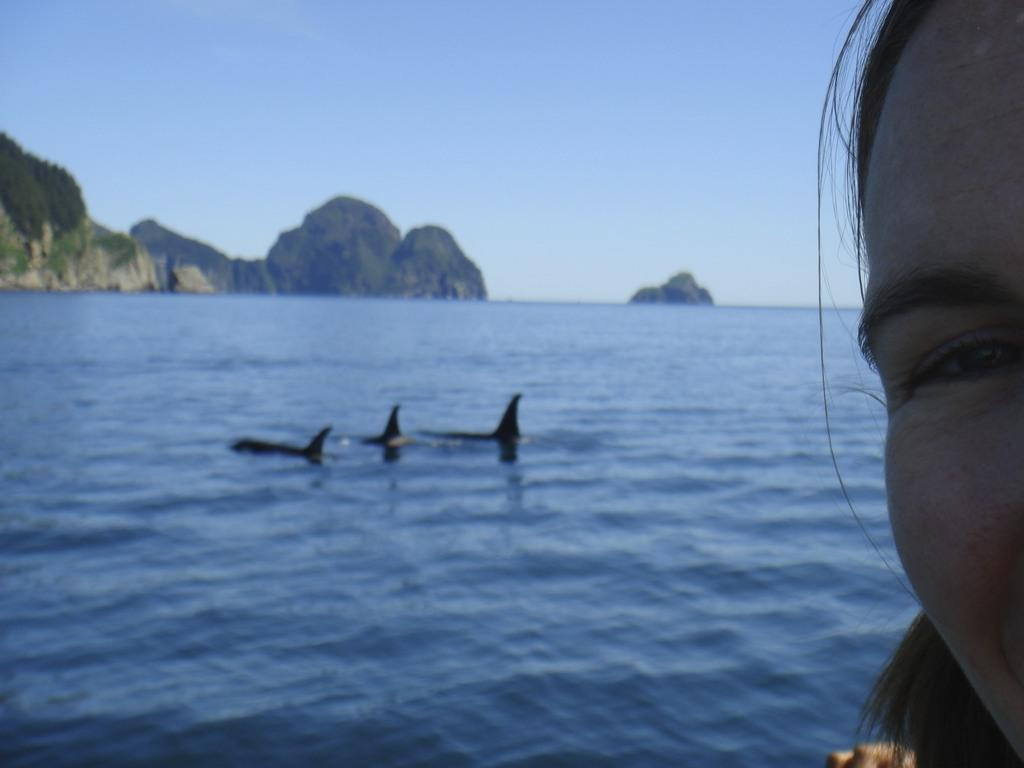What is the main subject of the image? There is a person's face in the image. What can be seen in the background of the image? There are aquatic animals in the water and trees with green color in the background. What type of natural elements are present in the image? There are rocks in the image, and the sky is in blue color. What type of hat is the person wearing in the image? There is no hat visible in the image; the focus is on the person's face. What type of cloud can be seen in the image? There is no cloud present in the image; the sky is in blue color. 